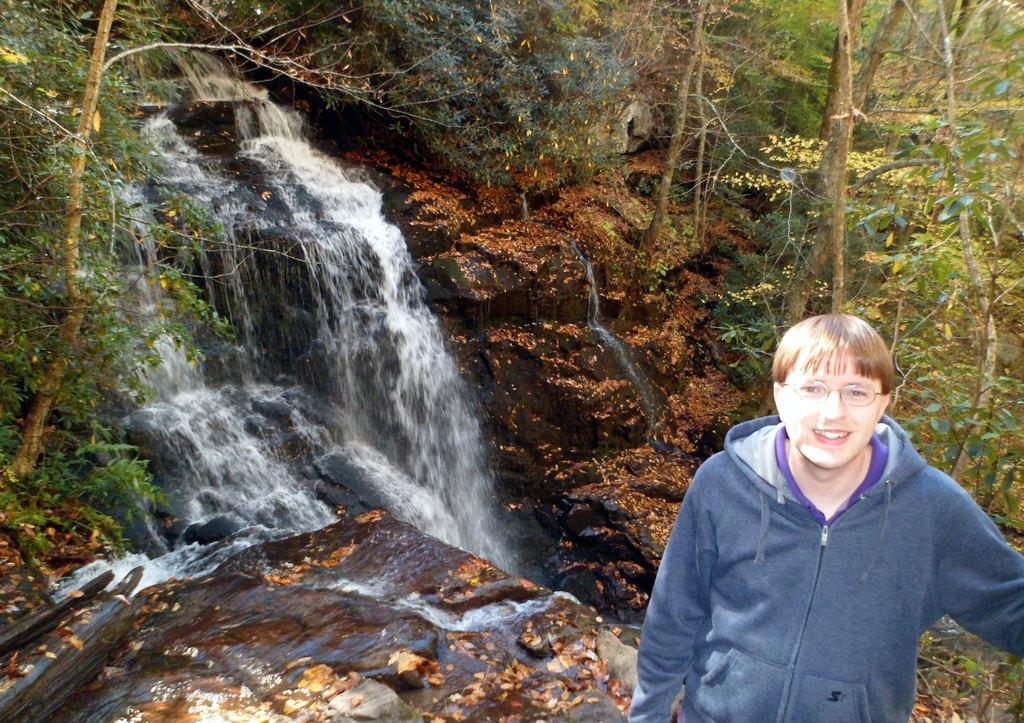Describe this image in one or two sentences. In this image there is a person with glasses and a jacket. In the background there are many trees. Waterfall is also visible in this image. 